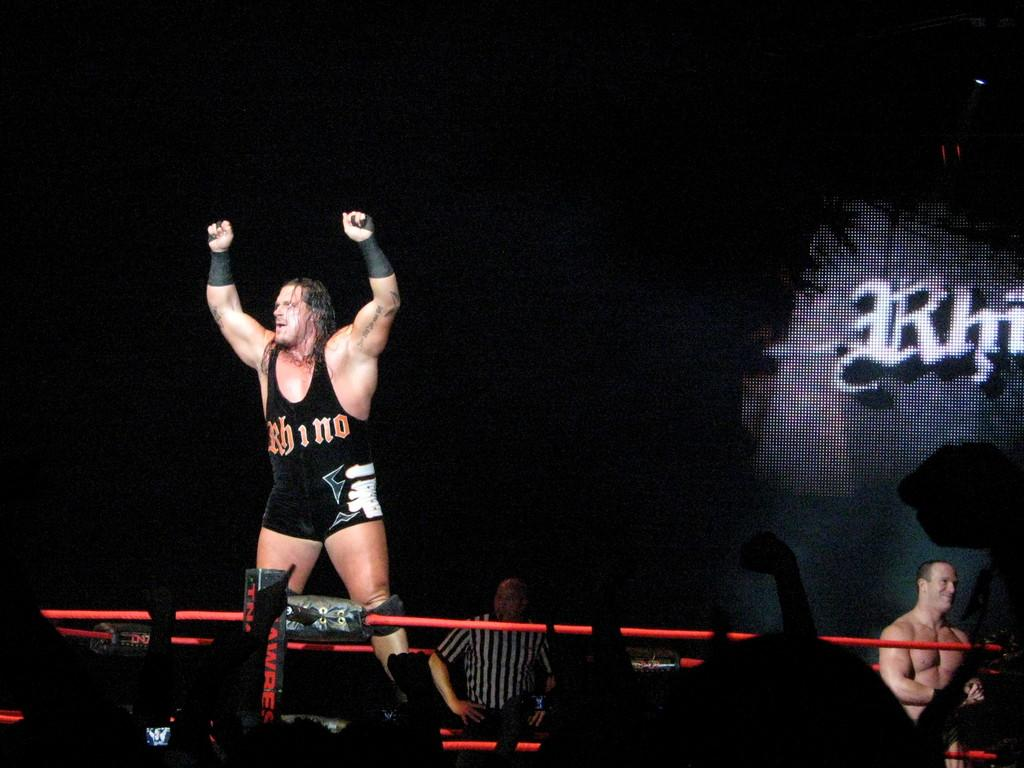<image>
Present a compact description of the photo's key features. a wrestler with the name of Rhino on themselves 